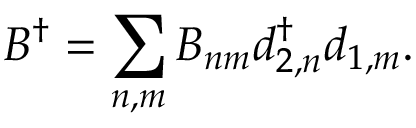<formula> <loc_0><loc_0><loc_500><loc_500>B ^ { \dagger } = \sum _ { n , m } B _ { n m } d _ { 2 , n } ^ { \dagger } d _ { 1 , m } .</formula> 